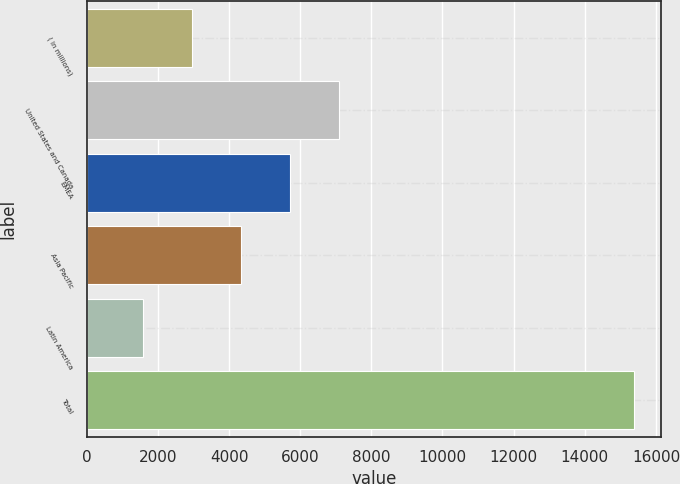Convert chart. <chart><loc_0><loc_0><loc_500><loc_500><bar_chart><fcel>( in millions)<fcel>United States and Canada<fcel>EMEA<fcel>Asia Pacific<fcel>Latin America<fcel>Total<nl><fcel>2971.1<fcel>7105.4<fcel>5727.3<fcel>4349.2<fcel>1593<fcel>15374<nl></chart> 